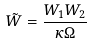Convert formula to latex. <formula><loc_0><loc_0><loc_500><loc_500>\tilde { W } = { \frac { W _ { 1 } W _ { 2 } } { \kappa \Omega } }</formula> 